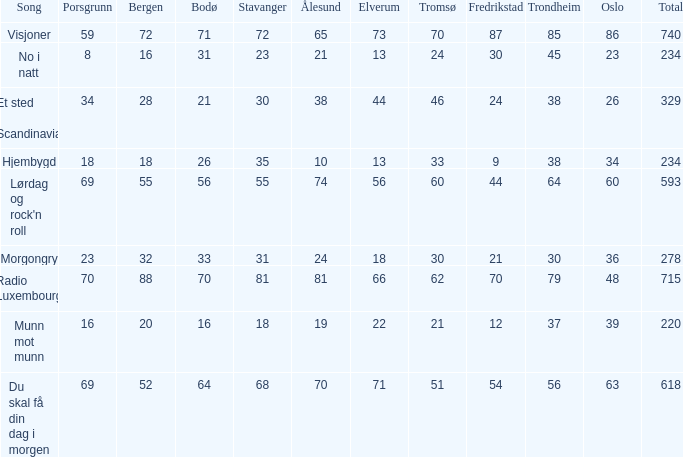In scandinavia, what is the count of elverum for a specific site? 1.0. 